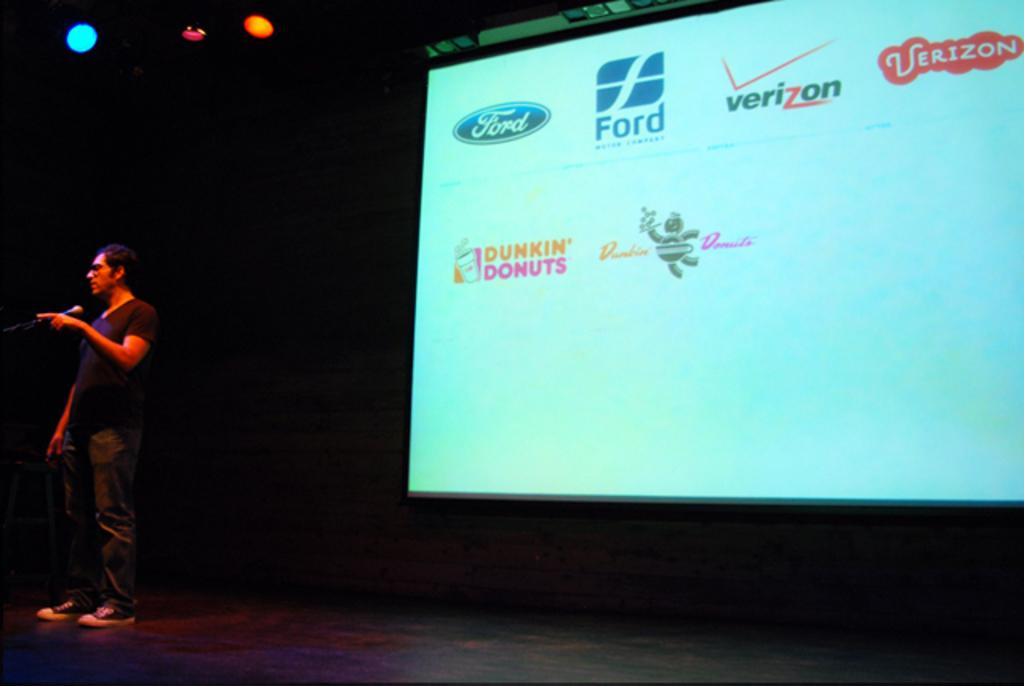<image>
Render a clear and concise summary of the photo. A man with a microphone and a screen with brands like Ford, Verizon and Dunkin' Donuts behind him. 